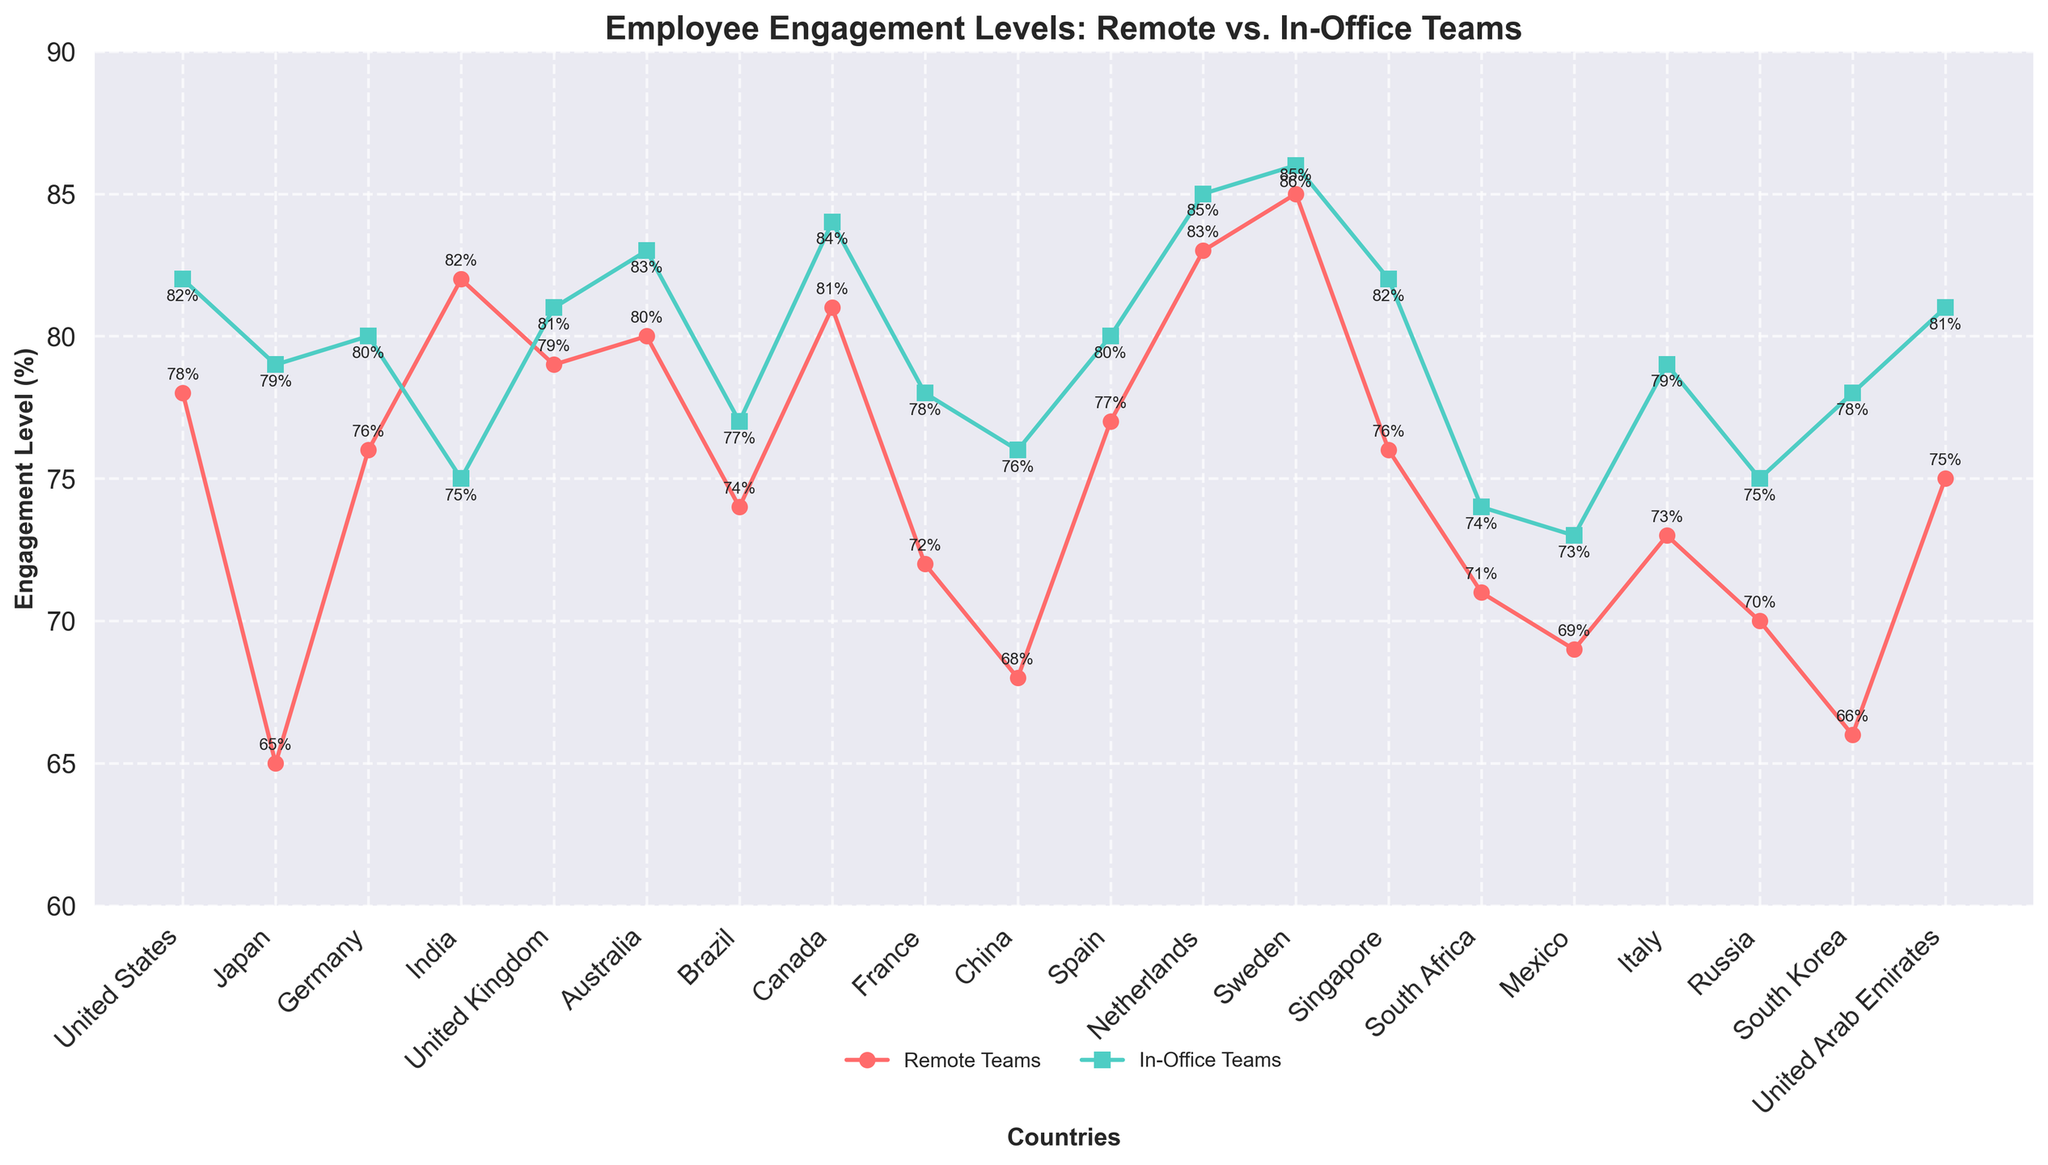Which country shows the highest engagement level for remote teams? By observing the peak points on the line representing remote teams, it is evident which country has the highest value. In this case, the peak point is for Sweden with an engagement level of 85%.
Answer: Sweden Which country has the smallest difference between remote and in-office engagement levels? To find this, we need to calculate the difference for each country and compare them. The smallest difference is the one close to the x-axis between the red and green lines, which is for Sweden (86% - 85% = 1%).
Answer: Sweden How many countries have higher remote team engagement compared to in-office teams? By comparing the heights of the markers for each country, we spot that only in India, the remote team engagement (82%) is higher than the in-office team engagement (75%).
Answer: 1 What is the average engagement level for in-office teams across all countries? Add the engagement levels for in-office teams across all countries and divide by the number of countries. The sum is 1565%, and there are 20 countries, so the average is 1565 ÷ 20 = 78.25%.
Answer: 78.25% Which two countries have the largest engagement difference between remote and in-office teams? Calculate the differences for each country and identify the two largest ones. Japan has an engagement difference of 14% (79% - 65%) and South Korea has a difference of 12% (78% - 66%).
Answer: Japan and South Korea Are there any countries where both remote and in-office teams have the same engagement level? Look for points on the chart where the markers for both lines are at the same height. There are no such points, as no country has equal engagement levels for both teams.
Answer: No Which country has the lowest engagement level for remote teams? Find the lowest point on the line representing remote team engagement. The lowest point is for Japan at 65%.
Answer: Japan How does the engagement level in Germany’s in-office teams compare to the average engagement level of in-office teams across all countries? Germany's in-office engagement level is 80%, and the average engagement level is 78.25%. So, Germany's level is higher.
Answer: Higher In which countries is the engagement level for remote teams below 70%? Identify the countries where the red markers fall below the 70% mark. These countries are Japan (65%), China (68%), and Mexico (69%).
Answer: Japan, China, and Mexico What is the average difference in engagement levels between remote and in-office teams for all countries? Calculate the difference for each country and find the average. Sum the differences: (4 + 14 + 4 + 7 + 2 + 3 + 3 + 3 + 6 + 8 + 3 + 2 + 1 + 6 + 3 + 4 + 6 + 5 + 12 + 6) = 96%, then divide by the number of countries (20). The average difference is 96 ÷ 20 = 4.8%.
Answer: 4.8% 